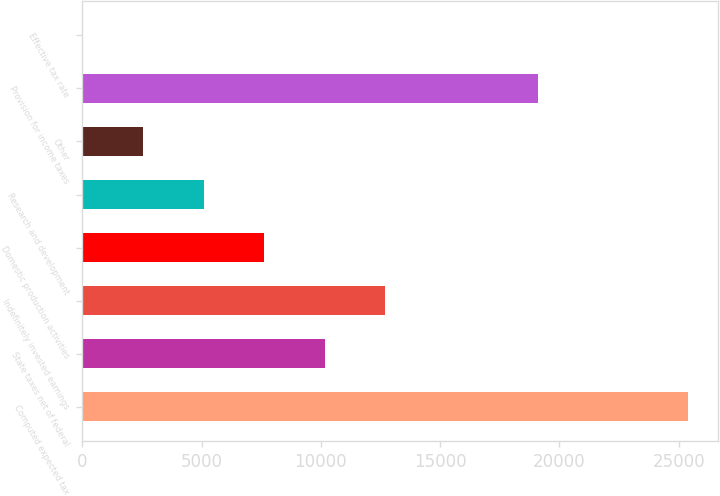<chart> <loc_0><loc_0><loc_500><loc_500><bar_chart><fcel>Computed expected tax<fcel>State taxes net of federal<fcel>Indefinitely invested earnings<fcel>Domestic production activities<fcel>Research and development<fcel>Other<fcel>Provision for income taxes<fcel>Effective tax rate<nl><fcel>25380<fcel>10167.8<fcel>12703.2<fcel>7632.48<fcel>5097.12<fcel>2561.76<fcel>19121<fcel>26.4<nl></chart> 